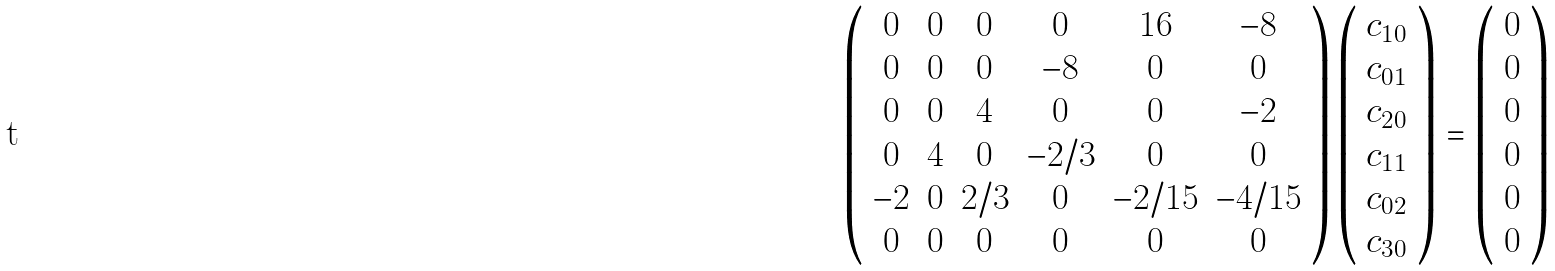<formula> <loc_0><loc_0><loc_500><loc_500>\left ( \begin{array} { c c c c c c } 0 & 0 & 0 & 0 & 1 6 & - 8 \\ 0 & 0 & 0 & - 8 & 0 & 0 \\ 0 & 0 & 4 & 0 & 0 & - 2 \\ 0 & 4 & 0 & - 2 / 3 & 0 & 0 \\ - 2 & 0 & 2 / 3 & 0 & - 2 / 1 5 & - 4 / 1 5 \\ 0 & 0 & 0 & 0 & 0 & 0 \\ \end{array} \right ) \left ( \begin{array} { c } c _ { 1 0 } \\ c _ { 0 1 } \\ c _ { 2 0 } \\ c _ { 1 1 } \\ c _ { 0 2 } \\ c _ { 3 0 } \\ \end{array} \right ) = \left ( \begin{array} { c } 0 \\ 0 \\ 0 \\ 0 \\ 0 \\ 0 \\ \end{array} \right )</formula> 